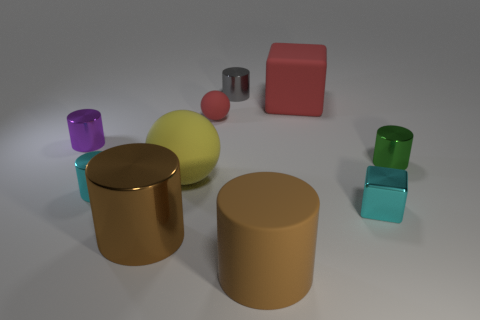Subtract all cyan cylinders. How many cylinders are left? 5 Subtract all tiny gray cylinders. How many cylinders are left? 5 Subtract all purple cylinders. Subtract all red cubes. How many cylinders are left? 5 Subtract all spheres. How many objects are left? 8 Add 2 large brown metal things. How many large brown metal things exist? 3 Subtract 1 gray cylinders. How many objects are left? 9 Subtract all small purple objects. Subtract all tiny gray metallic objects. How many objects are left? 8 Add 6 cyan things. How many cyan things are left? 8 